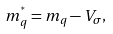<formula> <loc_0><loc_0><loc_500><loc_500>m _ { q } ^ { ^ { * } } = m _ { q } - V _ { \sigma } ,</formula> 